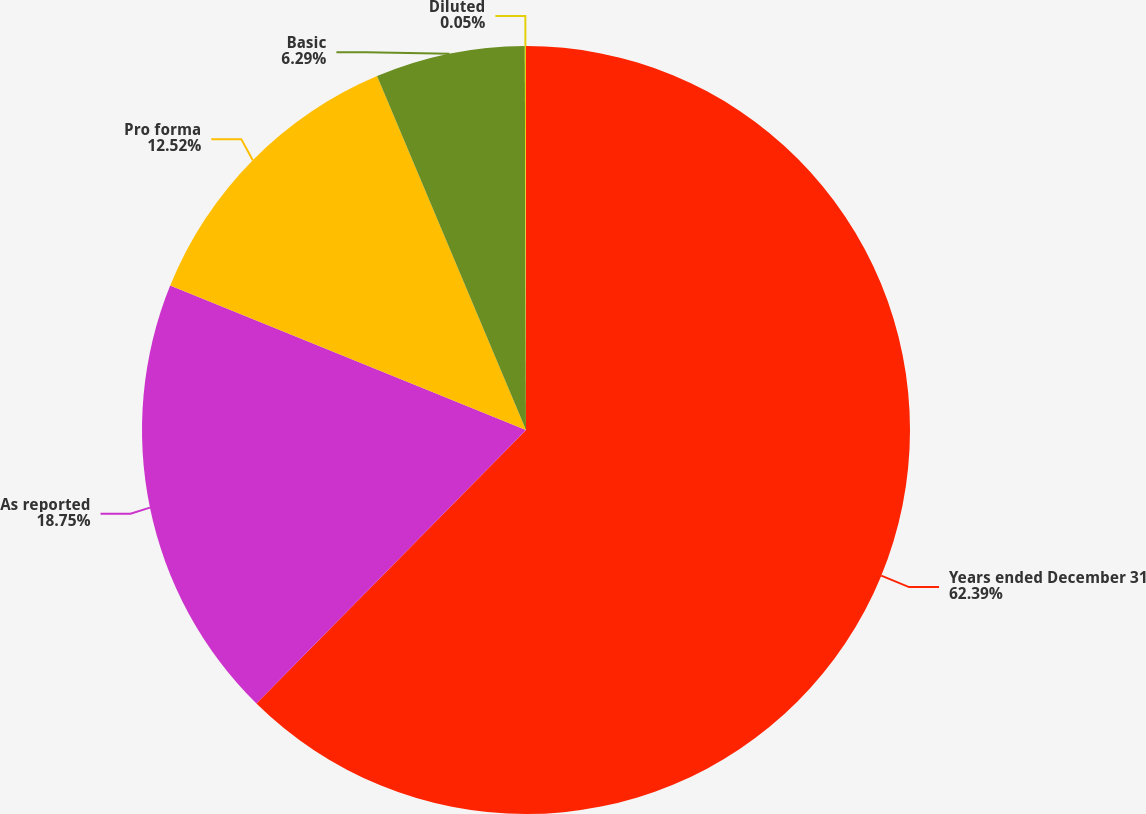Convert chart. <chart><loc_0><loc_0><loc_500><loc_500><pie_chart><fcel>Years ended December 31<fcel>As reported<fcel>Pro forma<fcel>Basic<fcel>Diluted<nl><fcel>62.38%<fcel>18.75%<fcel>12.52%<fcel>6.29%<fcel>0.05%<nl></chart> 